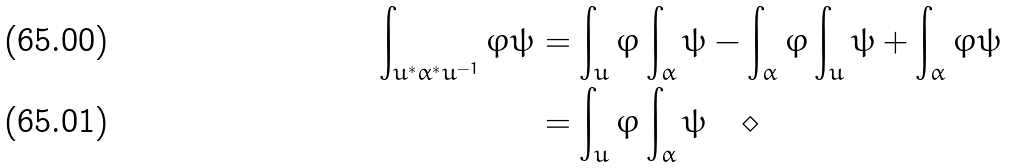<formula> <loc_0><loc_0><loc_500><loc_500>\int _ { u ^ { * } \alpha ^ { * } u ^ { - 1 } } \varphi \psi & = \int _ { u } \varphi \int _ { \alpha } \psi - \int _ { \alpha } \varphi \int _ { u } \psi + \int _ { \alpha } \varphi \psi \\ & = \int _ { u } \varphi \int _ { \alpha } \psi \quad \diamond</formula> 